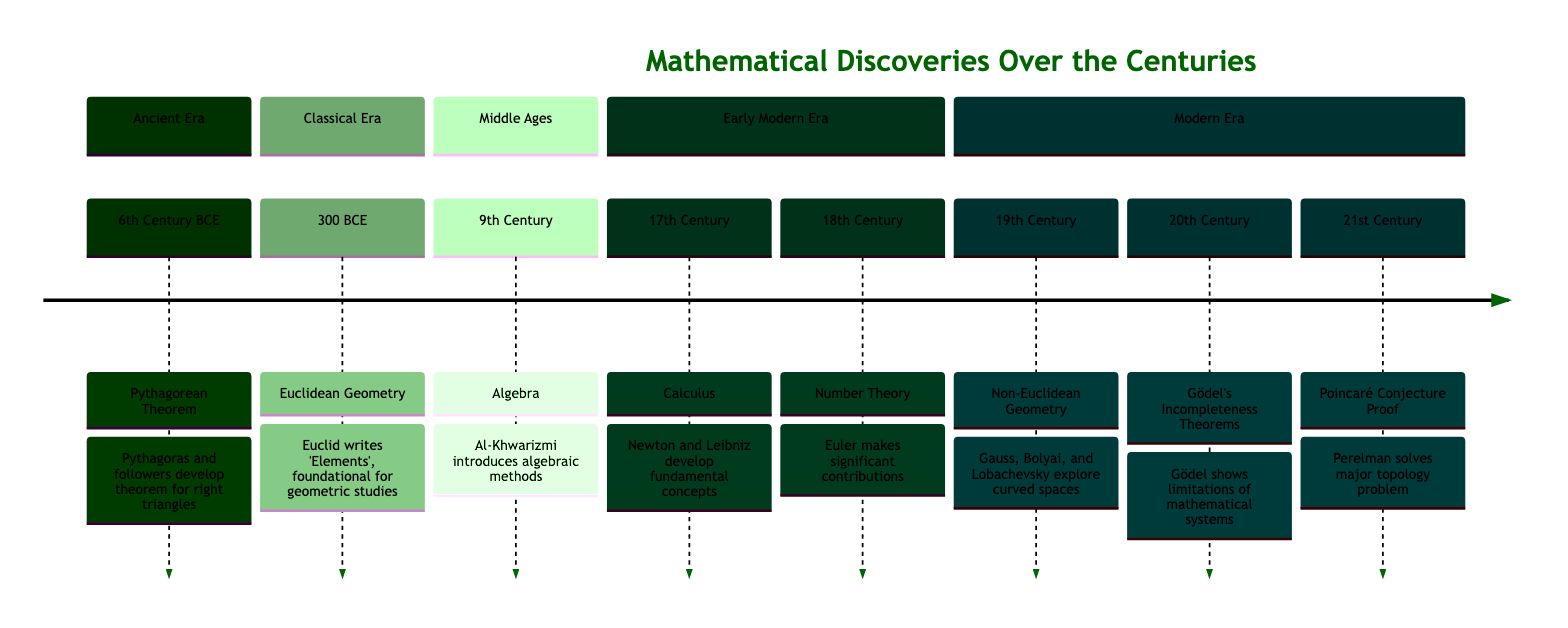What is the first event in the timeline? The first event listed in the timeline is the Pythagorean Theorem, which is placed in the 6th Century BCE.
Answer: Pythagorean Theorem Which century did Euclid write 'Elements'? According to the timeline, Euclid wrote 'Elements' in 300 BCE, which is clearly indicated in the Classical Era section.
Answer: 300 BCE What mathematical concept was introduced by Al-Khwarizmi in the 9th Century? The timeline states that Al-Khwarizmi introduced Algebra by writing 'The Compendious Book on Calculation by Completion and Balancing' in the 9th Century.
Answer: Algebra How many significant mathematical events are listed in the 20th Century? In the timeline, only one event is listed for the 20th Century, which is Gödel's Incompleteness Theorems.
Answer: 1 Which mathematician is associated with the concept of Non-Euclidean Geometry? The timeline mentions that mathematicians like Carl Friedrich Gauss, János Bolyai, and Nikolai Lobachevsky contributed to Non-Euclidean Geometry, indicating multiple associations.
Answer: Gauss, Bolyai, and Lobachevsky What discovery was made in the 21st Century? The timeline specifies that Grigori Perelman proved the Poincaré Conjecture in the 21st Century, detailing this significant mathematical discovery.
Answer: Poincaré Conjecture Proof Which two mathematicians developed calculus in the 17th Century? The timeline declares that Isaac Newton and Gottfried Wilhelm Leibniz are the two mathematicians credited with the development of calculus during the 17th Century.
Answer: Newton and Leibniz What major theorem was published by Kurt Gödel? According to the timeline, Gödel published his Incompleteness Theorems, which highlight limitations in mathematical systems and are an important aspect of 20th Century mathematics.
Answer: Gödel's Incompleteness Theorems 